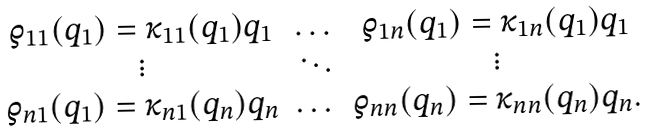Convert formula to latex. <formula><loc_0><loc_0><loc_500><loc_500>\begin{array} { c c c } \varrho _ { 1 1 } ( q _ { 1 } ) = \kappa _ { 1 1 } ( q _ { 1 } ) q _ { 1 } & \dots & \varrho _ { 1 n } ( q _ { 1 } ) = \kappa _ { 1 n } ( q _ { 1 } ) q _ { 1 } \\ \vdots & \ddots & \vdots \\ \varrho _ { n 1 } ( q _ { 1 } ) = \kappa _ { n 1 } ( q _ { n } ) q _ { n } & \dots & \varrho _ { n n } ( q _ { n } ) = \kappa _ { n n } ( q _ { n } ) q _ { n } . \end{array}</formula> 